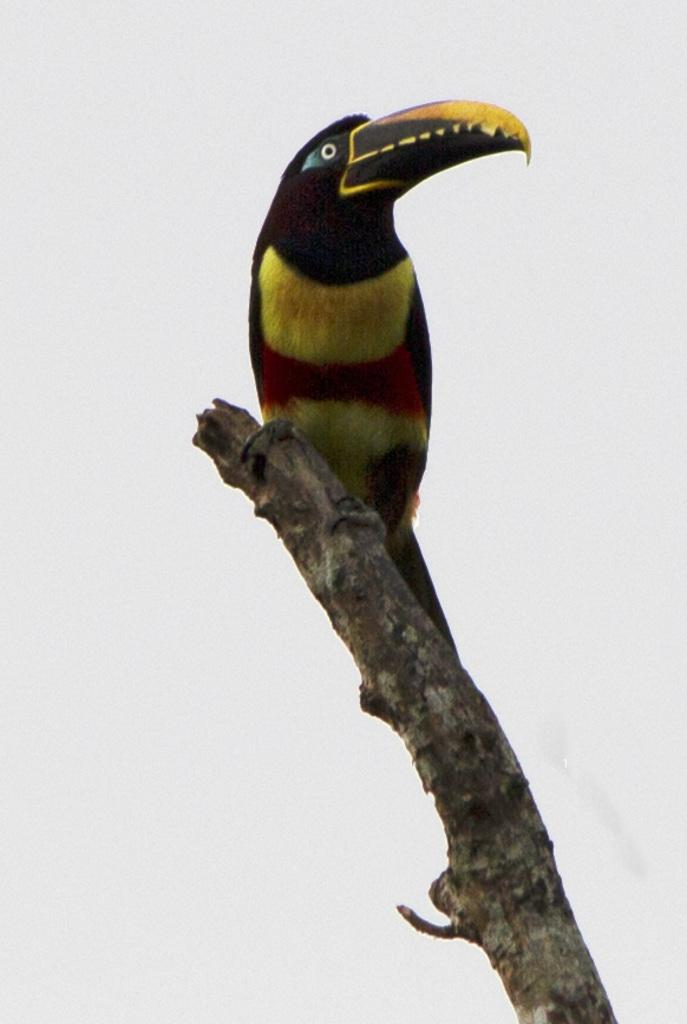What type of animal can be seen in the image? There is a bird in the image. Where is the bird located? The bird is on a wooden object. What color is the background of the image? The background of the image is white. What type of coast can be seen in the image? There is no coast present in the image; it features a bird on a wooden object with a white background. What grade is the bird in the image? The bird is not in a grade, as it is an animal and not a student. 